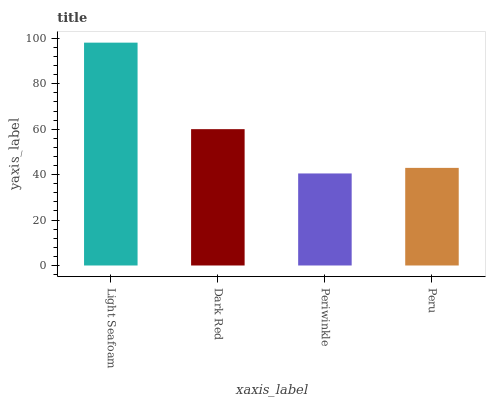Is Periwinkle the minimum?
Answer yes or no. Yes. Is Light Seafoam the maximum?
Answer yes or no. Yes. Is Dark Red the minimum?
Answer yes or no. No. Is Dark Red the maximum?
Answer yes or no. No. Is Light Seafoam greater than Dark Red?
Answer yes or no. Yes. Is Dark Red less than Light Seafoam?
Answer yes or no. Yes. Is Dark Red greater than Light Seafoam?
Answer yes or no. No. Is Light Seafoam less than Dark Red?
Answer yes or no. No. Is Dark Red the high median?
Answer yes or no. Yes. Is Peru the low median?
Answer yes or no. Yes. Is Periwinkle the high median?
Answer yes or no. No. Is Light Seafoam the low median?
Answer yes or no. No. 